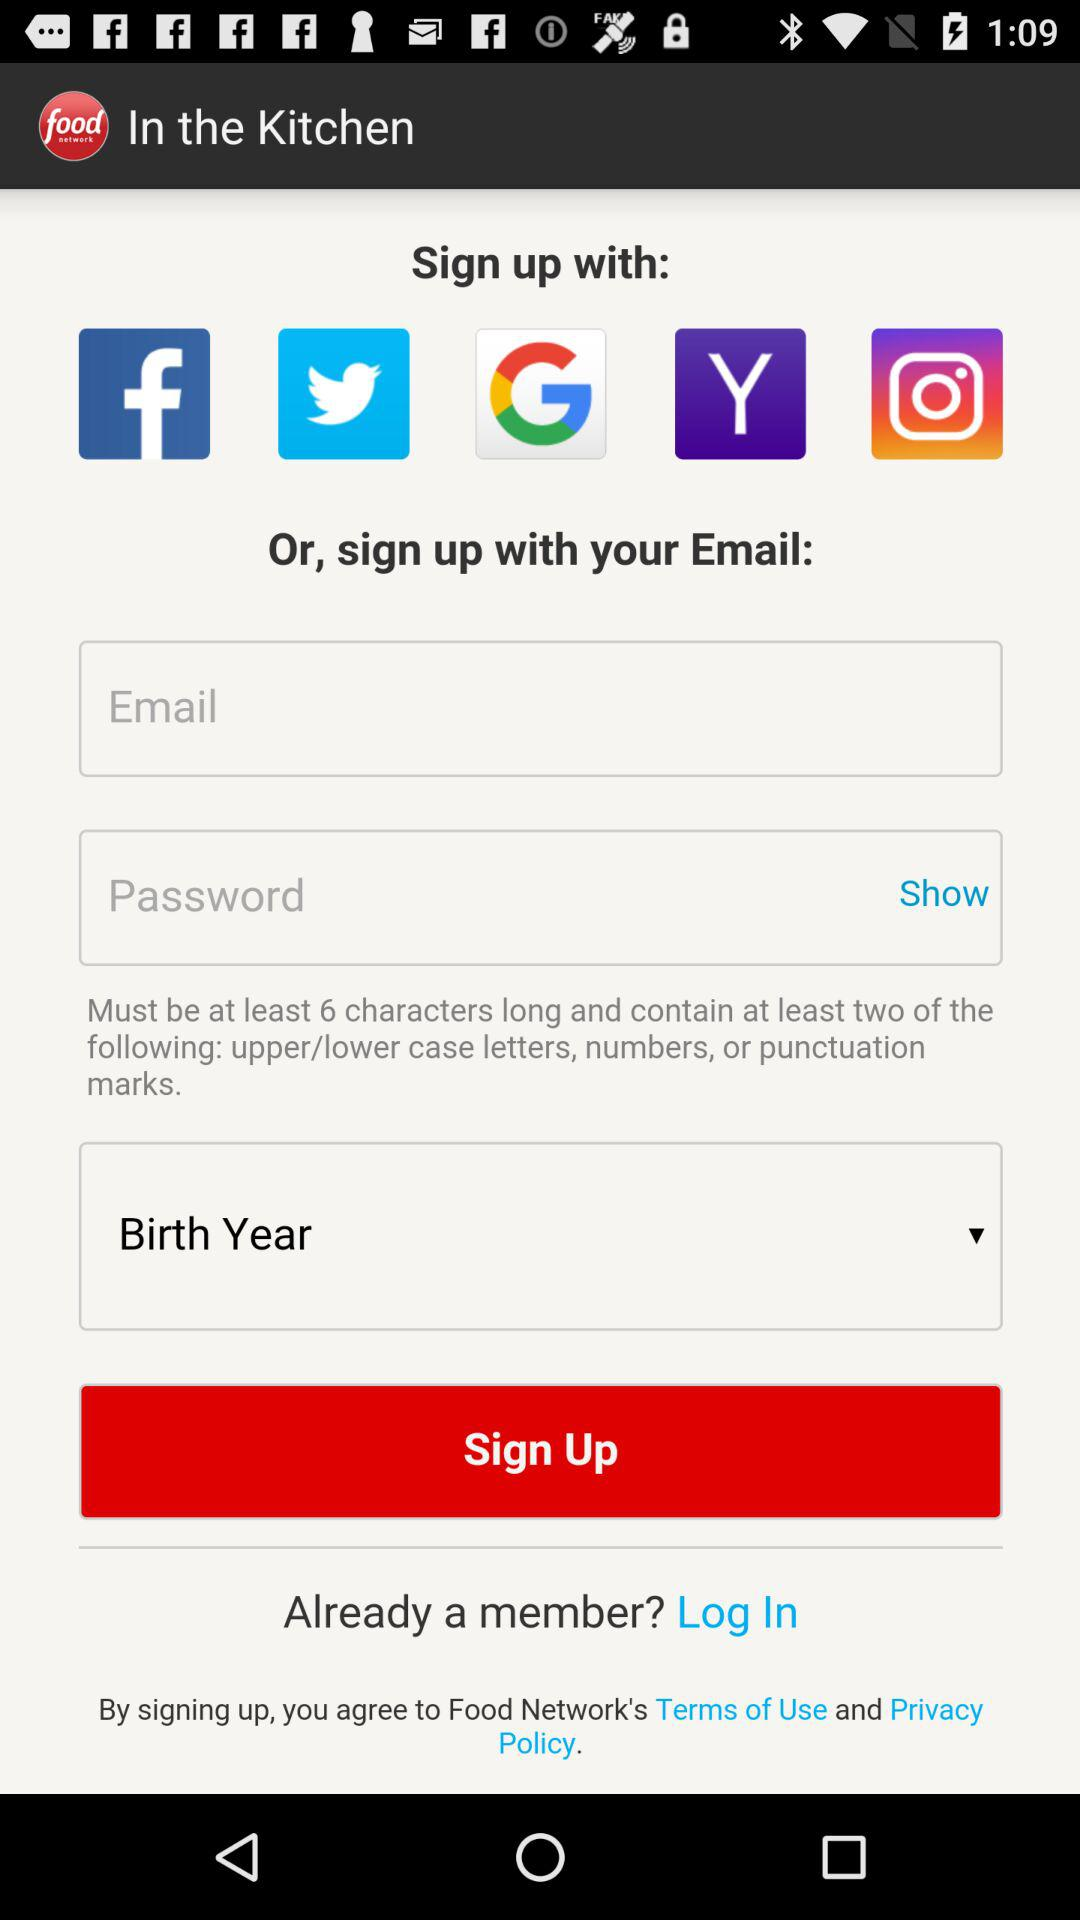What accounts can I use to sign up? You can use "Facebook", "Twitter", "Google", "Yahoo", "Instagram" and "Email" to sign up. 